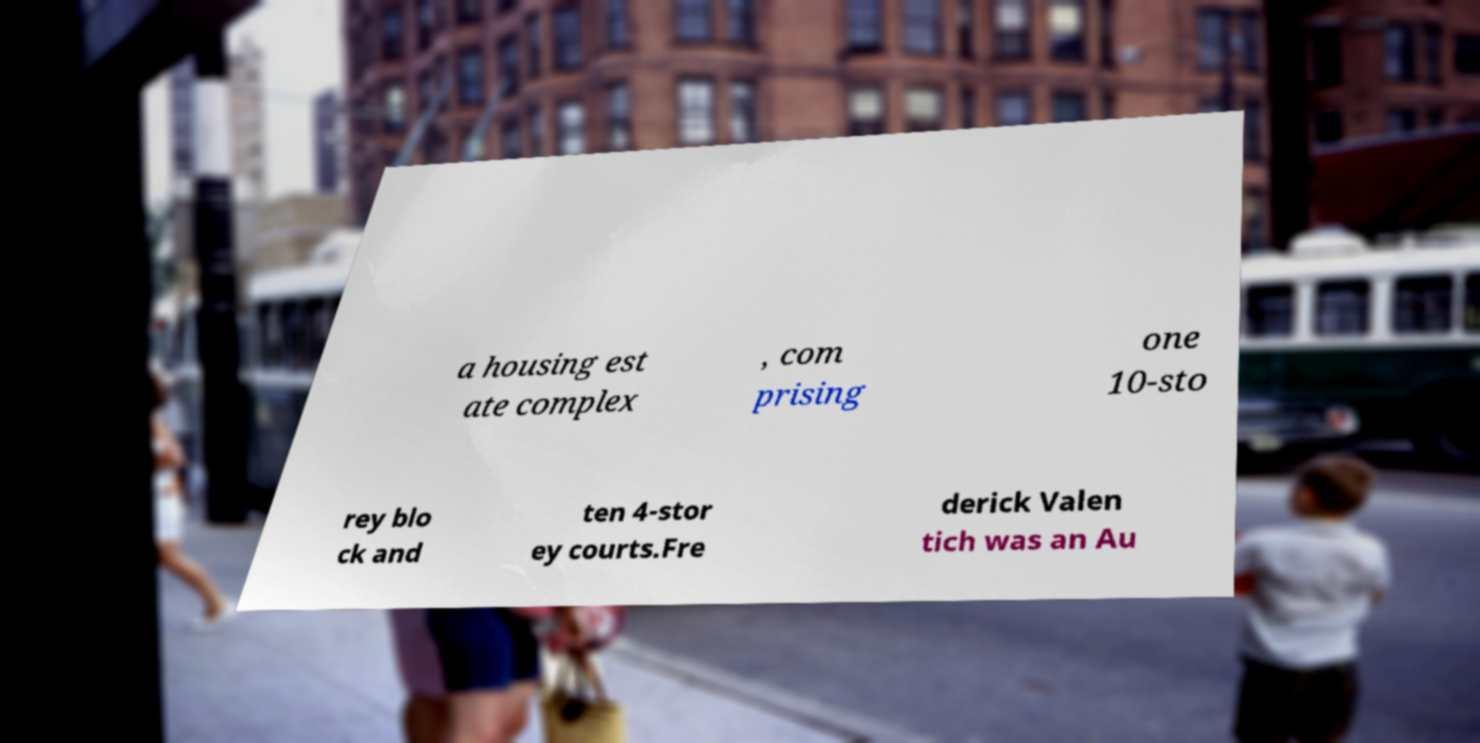I need the written content from this picture converted into text. Can you do that? a housing est ate complex , com prising one 10-sto rey blo ck and ten 4-stor ey courts.Fre derick Valen tich was an Au 